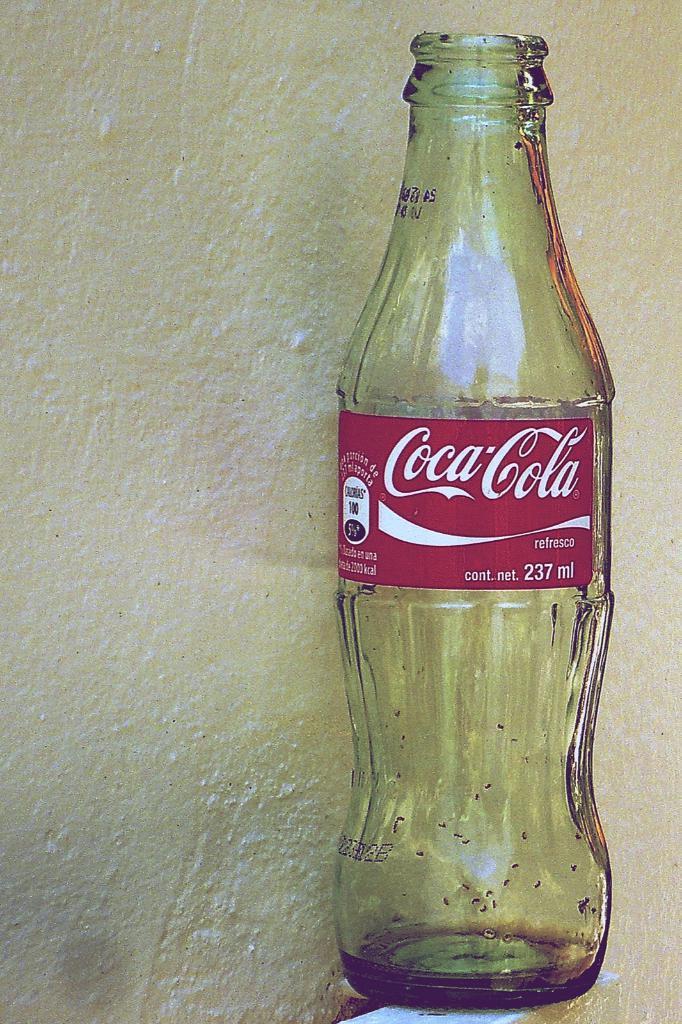Could you give a brief overview of what you see in this image? As we can see in the image there is a glass bottle and coca-cola was written on it. 